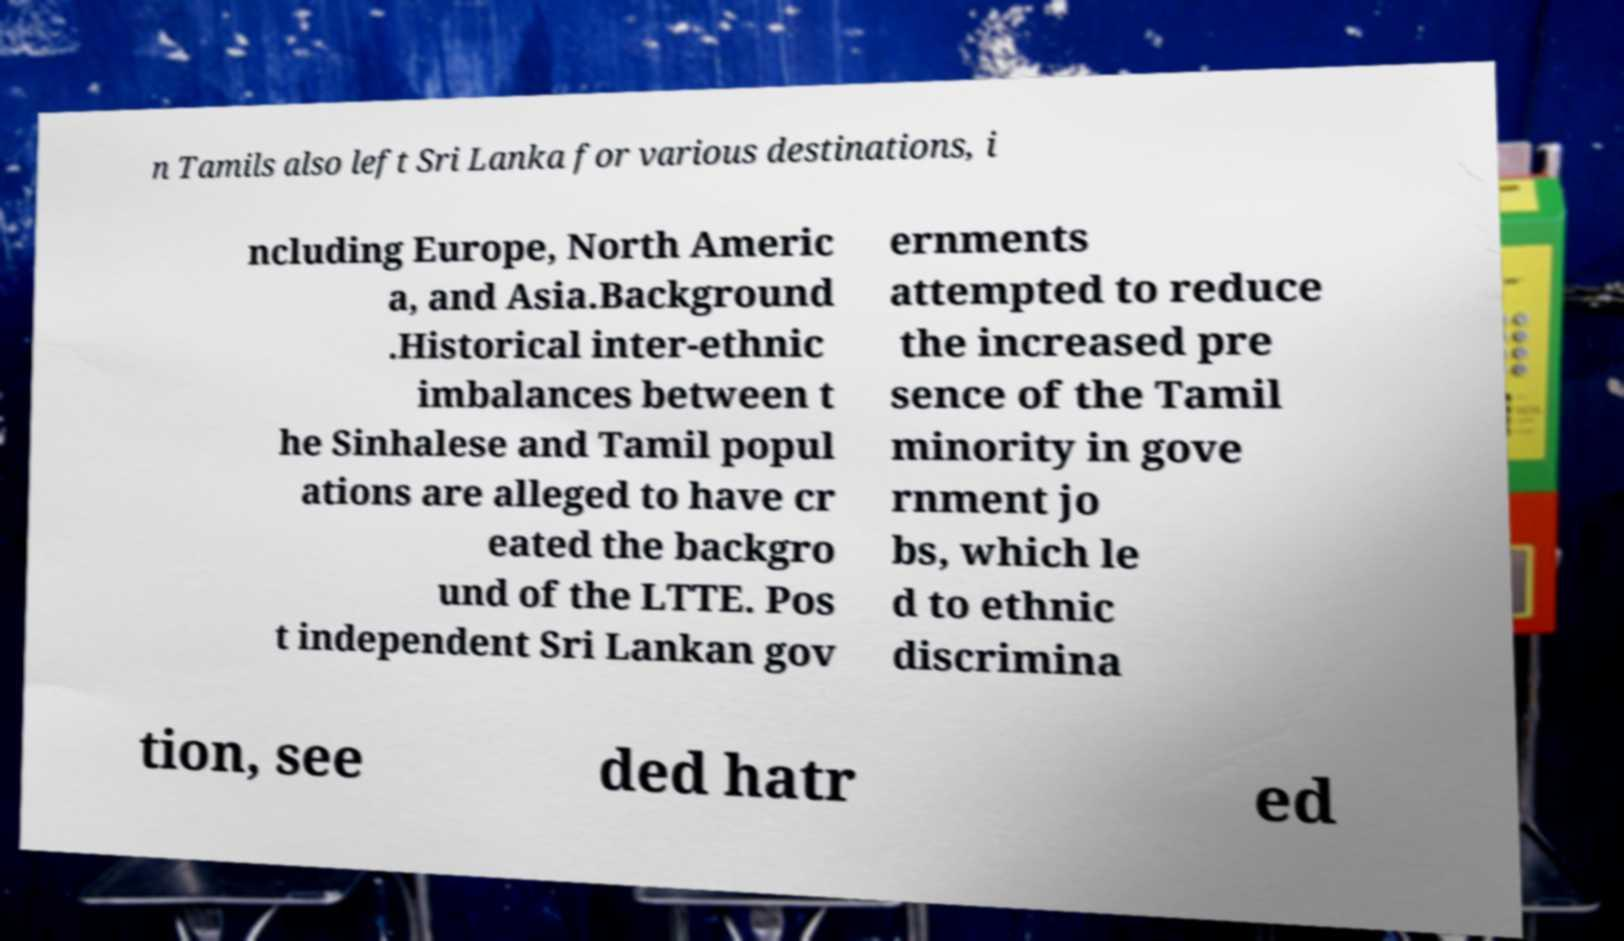Can you read and provide the text displayed in the image?This photo seems to have some interesting text. Can you extract and type it out for me? n Tamils also left Sri Lanka for various destinations, i ncluding Europe, North Americ a, and Asia.Background .Historical inter-ethnic imbalances between t he Sinhalese and Tamil popul ations are alleged to have cr eated the backgro und of the LTTE. Pos t independent Sri Lankan gov ernments attempted to reduce the increased pre sence of the Tamil minority in gove rnment jo bs, which le d to ethnic discrimina tion, see ded hatr ed 